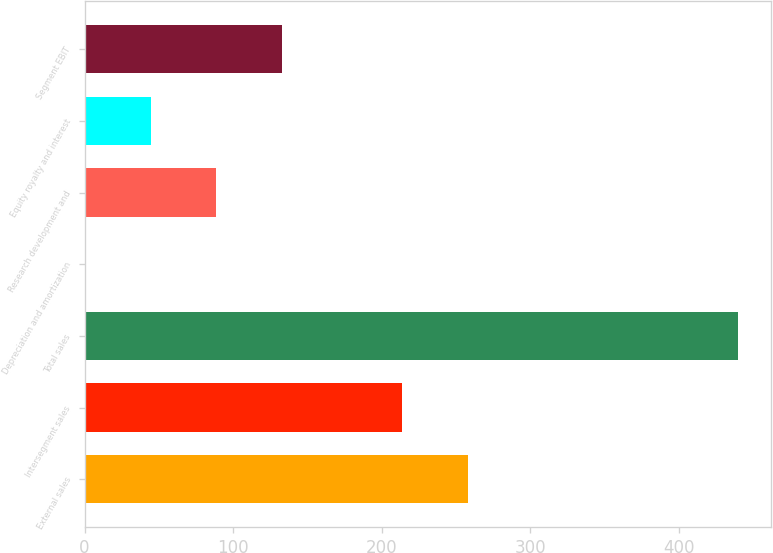Convert chart to OTSL. <chart><loc_0><loc_0><loc_500><loc_500><bar_chart><fcel>External sales<fcel>Intersegment sales<fcel>Total sales<fcel>Depreciation and amortization<fcel>Research development and<fcel>Equity royalty and interest<fcel>Segment EBIT<nl><fcel>257.9<fcel>214<fcel>440<fcel>1<fcel>88.8<fcel>44.9<fcel>132.7<nl></chart> 